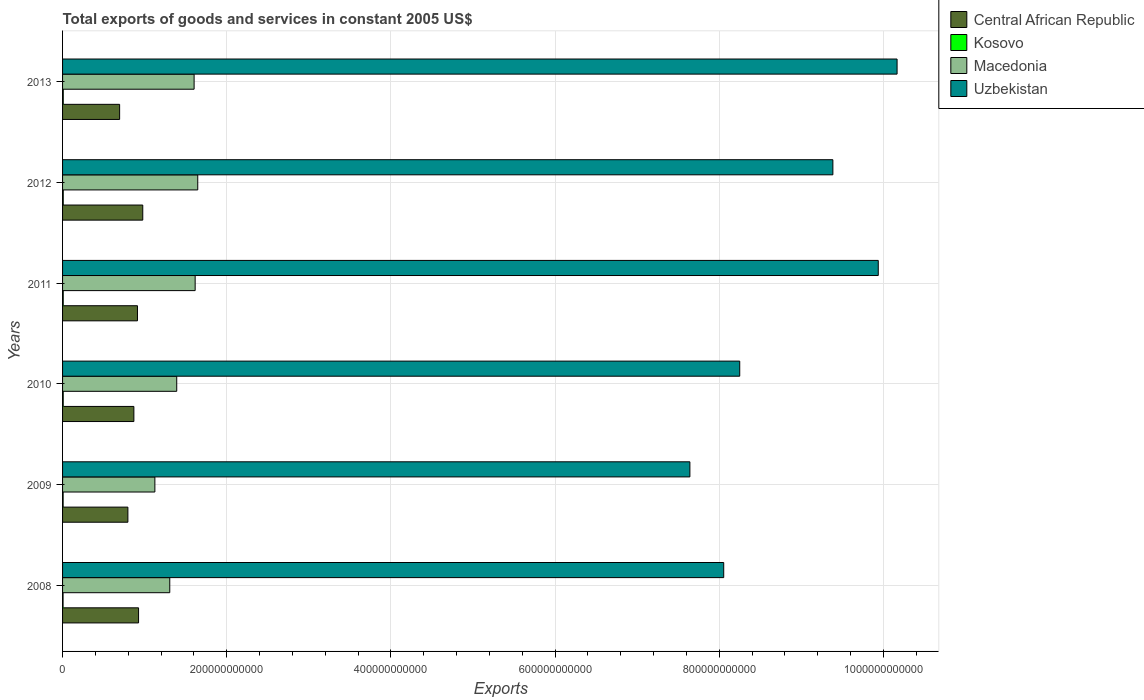How many different coloured bars are there?
Make the answer very short. 4. How many bars are there on the 4th tick from the top?
Your answer should be very brief. 4. What is the total exports of goods and services in Central African Republic in 2008?
Make the answer very short. 9.26e+1. Across all years, what is the maximum total exports of goods and services in Uzbekistan?
Offer a terse response. 1.02e+12. Across all years, what is the minimum total exports of goods and services in Central African Republic?
Ensure brevity in your answer.  6.95e+1. In which year was the total exports of goods and services in Central African Republic maximum?
Your response must be concise. 2012. In which year was the total exports of goods and services in Kosovo minimum?
Offer a very short reply. 2008. What is the total total exports of goods and services in Kosovo in the graph?
Offer a terse response. 4.49e+09. What is the difference between the total exports of goods and services in Uzbekistan in 2011 and that in 2012?
Your answer should be compact. 5.53e+1. What is the difference between the total exports of goods and services in Macedonia in 2011 and the total exports of goods and services in Uzbekistan in 2012?
Make the answer very short. -7.77e+11. What is the average total exports of goods and services in Macedonia per year?
Provide a succinct answer. 1.45e+11. In the year 2012, what is the difference between the total exports of goods and services in Central African Republic and total exports of goods and services in Uzbekistan?
Provide a short and direct response. -8.41e+11. In how many years, is the total exports of goods and services in Central African Republic greater than 480000000000 US$?
Keep it short and to the point. 0. What is the ratio of the total exports of goods and services in Uzbekistan in 2009 to that in 2013?
Your answer should be compact. 0.75. Is the total exports of goods and services in Uzbekistan in 2008 less than that in 2011?
Provide a succinct answer. Yes. Is the difference between the total exports of goods and services in Central African Republic in 2008 and 2010 greater than the difference between the total exports of goods and services in Uzbekistan in 2008 and 2010?
Your response must be concise. Yes. What is the difference between the highest and the second highest total exports of goods and services in Macedonia?
Ensure brevity in your answer.  3.15e+09. What is the difference between the highest and the lowest total exports of goods and services in Central African Republic?
Give a very brief answer. 2.82e+1. Is it the case that in every year, the sum of the total exports of goods and services in Kosovo and total exports of goods and services in Macedonia is greater than the sum of total exports of goods and services in Central African Republic and total exports of goods and services in Uzbekistan?
Provide a short and direct response. No. What does the 2nd bar from the top in 2010 represents?
Make the answer very short. Macedonia. What does the 3rd bar from the bottom in 2011 represents?
Give a very brief answer. Macedonia. How many bars are there?
Offer a very short reply. 24. What is the difference between two consecutive major ticks on the X-axis?
Your answer should be very brief. 2.00e+11. Does the graph contain any zero values?
Provide a succinct answer. No. Does the graph contain grids?
Offer a terse response. Yes. How are the legend labels stacked?
Make the answer very short. Vertical. What is the title of the graph?
Keep it short and to the point. Total exports of goods and services in constant 2005 US$. Does "Canada" appear as one of the legend labels in the graph?
Your answer should be compact. No. What is the label or title of the X-axis?
Provide a succinct answer. Exports. What is the Exports in Central African Republic in 2008?
Make the answer very short. 9.26e+1. What is the Exports in Kosovo in 2008?
Offer a terse response. 6.09e+08. What is the Exports of Macedonia in 2008?
Offer a terse response. 1.31e+11. What is the Exports of Uzbekistan in 2008?
Offer a very short reply. 8.05e+11. What is the Exports of Central African Republic in 2009?
Provide a short and direct response. 7.96e+1. What is the Exports in Kosovo in 2009?
Provide a succinct answer. 6.85e+08. What is the Exports in Macedonia in 2009?
Your answer should be compact. 1.12e+11. What is the Exports of Uzbekistan in 2009?
Ensure brevity in your answer.  7.64e+11. What is the Exports in Central African Republic in 2010?
Make the answer very short. 8.69e+1. What is the Exports of Kosovo in 2010?
Ensure brevity in your answer.  7.70e+08. What is the Exports in Macedonia in 2010?
Provide a short and direct response. 1.39e+11. What is the Exports of Uzbekistan in 2010?
Your response must be concise. 8.25e+11. What is the Exports of Central African Republic in 2011?
Make the answer very short. 9.13e+1. What is the Exports in Kosovo in 2011?
Offer a very short reply. 8.00e+08. What is the Exports of Macedonia in 2011?
Make the answer very short. 1.62e+11. What is the Exports of Uzbekistan in 2011?
Your answer should be compact. 9.94e+11. What is the Exports in Central African Republic in 2012?
Offer a terse response. 9.77e+1. What is the Exports in Kosovo in 2012?
Your answer should be very brief. 8.06e+08. What is the Exports of Macedonia in 2012?
Make the answer very short. 1.65e+11. What is the Exports in Uzbekistan in 2012?
Your response must be concise. 9.38e+11. What is the Exports in Central African Republic in 2013?
Your answer should be compact. 6.95e+1. What is the Exports in Kosovo in 2013?
Keep it short and to the point. 8.24e+08. What is the Exports of Macedonia in 2013?
Give a very brief answer. 1.60e+11. What is the Exports of Uzbekistan in 2013?
Provide a succinct answer. 1.02e+12. Across all years, what is the maximum Exports of Central African Republic?
Provide a succinct answer. 9.77e+1. Across all years, what is the maximum Exports of Kosovo?
Provide a short and direct response. 8.24e+08. Across all years, what is the maximum Exports in Macedonia?
Your answer should be very brief. 1.65e+11. Across all years, what is the maximum Exports in Uzbekistan?
Provide a succinct answer. 1.02e+12. Across all years, what is the minimum Exports of Central African Republic?
Your answer should be very brief. 6.95e+1. Across all years, what is the minimum Exports in Kosovo?
Ensure brevity in your answer.  6.09e+08. Across all years, what is the minimum Exports in Macedonia?
Offer a very short reply. 1.12e+11. Across all years, what is the minimum Exports in Uzbekistan?
Provide a succinct answer. 7.64e+11. What is the total Exports of Central African Republic in the graph?
Your response must be concise. 5.18e+11. What is the total Exports in Kosovo in the graph?
Provide a succinct answer. 4.49e+09. What is the total Exports in Macedonia in the graph?
Provide a short and direct response. 8.69e+11. What is the total Exports of Uzbekistan in the graph?
Ensure brevity in your answer.  5.34e+12. What is the difference between the Exports of Central African Republic in 2008 and that in 2009?
Make the answer very short. 1.30e+1. What is the difference between the Exports in Kosovo in 2008 and that in 2009?
Your answer should be compact. -7.59e+07. What is the difference between the Exports of Macedonia in 2008 and that in 2009?
Offer a very short reply. 1.81e+1. What is the difference between the Exports in Uzbekistan in 2008 and that in 2009?
Provide a succinct answer. 4.12e+1. What is the difference between the Exports in Central African Republic in 2008 and that in 2010?
Your response must be concise. 5.71e+09. What is the difference between the Exports of Kosovo in 2008 and that in 2010?
Your response must be concise. -1.62e+08. What is the difference between the Exports of Macedonia in 2008 and that in 2010?
Ensure brevity in your answer.  -8.49e+09. What is the difference between the Exports in Uzbekistan in 2008 and that in 2010?
Offer a terse response. -1.95e+1. What is the difference between the Exports in Central African Republic in 2008 and that in 2011?
Your response must be concise. 1.33e+09. What is the difference between the Exports of Kosovo in 2008 and that in 2011?
Your answer should be compact. -1.91e+08. What is the difference between the Exports in Macedonia in 2008 and that in 2011?
Make the answer very short. -3.09e+1. What is the difference between the Exports in Uzbekistan in 2008 and that in 2011?
Offer a very short reply. -1.88e+11. What is the difference between the Exports in Central African Republic in 2008 and that in 2012?
Offer a very short reply. -5.11e+09. What is the difference between the Exports of Kosovo in 2008 and that in 2012?
Offer a terse response. -1.97e+08. What is the difference between the Exports of Macedonia in 2008 and that in 2012?
Provide a succinct answer. -3.41e+1. What is the difference between the Exports of Uzbekistan in 2008 and that in 2012?
Give a very brief answer. -1.33e+11. What is the difference between the Exports of Central African Republic in 2008 and that in 2013?
Provide a short and direct response. 2.31e+1. What is the difference between the Exports of Kosovo in 2008 and that in 2013?
Provide a succinct answer. -2.15e+08. What is the difference between the Exports in Macedonia in 2008 and that in 2013?
Make the answer very short. -2.97e+1. What is the difference between the Exports of Uzbekistan in 2008 and that in 2013?
Keep it short and to the point. -2.11e+11. What is the difference between the Exports of Central African Republic in 2009 and that in 2010?
Your answer should be compact. -7.29e+09. What is the difference between the Exports in Kosovo in 2009 and that in 2010?
Your response must be concise. -8.56e+07. What is the difference between the Exports of Macedonia in 2009 and that in 2010?
Give a very brief answer. -2.66e+1. What is the difference between the Exports in Uzbekistan in 2009 and that in 2010?
Your answer should be compact. -6.07e+1. What is the difference between the Exports of Central African Republic in 2009 and that in 2011?
Give a very brief answer. -1.17e+1. What is the difference between the Exports in Kosovo in 2009 and that in 2011?
Your answer should be very brief. -1.15e+08. What is the difference between the Exports in Macedonia in 2009 and that in 2011?
Make the answer very short. -4.91e+1. What is the difference between the Exports of Uzbekistan in 2009 and that in 2011?
Give a very brief answer. -2.29e+11. What is the difference between the Exports in Central African Republic in 2009 and that in 2012?
Provide a short and direct response. -1.81e+1. What is the difference between the Exports of Kosovo in 2009 and that in 2012?
Your answer should be compact. -1.21e+08. What is the difference between the Exports in Macedonia in 2009 and that in 2012?
Ensure brevity in your answer.  -5.22e+1. What is the difference between the Exports in Uzbekistan in 2009 and that in 2012?
Make the answer very short. -1.74e+11. What is the difference between the Exports of Central African Republic in 2009 and that in 2013?
Ensure brevity in your answer.  1.01e+1. What is the difference between the Exports of Kosovo in 2009 and that in 2013?
Ensure brevity in your answer.  -1.39e+08. What is the difference between the Exports of Macedonia in 2009 and that in 2013?
Ensure brevity in your answer.  -4.78e+1. What is the difference between the Exports in Uzbekistan in 2009 and that in 2013?
Ensure brevity in your answer.  -2.52e+11. What is the difference between the Exports of Central African Republic in 2010 and that in 2011?
Ensure brevity in your answer.  -4.38e+09. What is the difference between the Exports of Kosovo in 2010 and that in 2011?
Offer a terse response. -2.96e+07. What is the difference between the Exports in Macedonia in 2010 and that in 2011?
Provide a succinct answer. -2.24e+1. What is the difference between the Exports of Uzbekistan in 2010 and that in 2011?
Give a very brief answer. -1.69e+11. What is the difference between the Exports in Central African Republic in 2010 and that in 2012?
Give a very brief answer. -1.08e+1. What is the difference between the Exports of Kosovo in 2010 and that in 2012?
Give a very brief answer. -3.52e+07. What is the difference between the Exports in Macedonia in 2010 and that in 2012?
Provide a succinct answer. -2.56e+1. What is the difference between the Exports of Uzbekistan in 2010 and that in 2012?
Give a very brief answer. -1.13e+11. What is the difference between the Exports of Central African Republic in 2010 and that in 2013?
Give a very brief answer. 1.74e+1. What is the difference between the Exports in Kosovo in 2010 and that in 2013?
Offer a very short reply. -5.38e+07. What is the difference between the Exports in Macedonia in 2010 and that in 2013?
Your answer should be compact. -2.12e+1. What is the difference between the Exports in Uzbekistan in 2010 and that in 2013?
Your answer should be compact. -1.92e+11. What is the difference between the Exports of Central African Republic in 2011 and that in 2012?
Make the answer very short. -6.44e+09. What is the difference between the Exports of Kosovo in 2011 and that in 2012?
Offer a terse response. -5.60e+06. What is the difference between the Exports in Macedonia in 2011 and that in 2012?
Make the answer very short. -3.15e+09. What is the difference between the Exports in Uzbekistan in 2011 and that in 2012?
Ensure brevity in your answer.  5.53e+1. What is the difference between the Exports of Central African Republic in 2011 and that in 2013?
Your answer should be compact. 2.17e+1. What is the difference between the Exports of Kosovo in 2011 and that in 2013?
Ensure brevity in your answer.  -2.42e+07. What is the difference between the Exports of Macedonia in 2011 and that in 2013?
Provide a succinct answer. 1.27e+09. What is the difference between the Exports in Uzbekistan in 2011 and that in 2013?
Your answer should be compact. -2.29e+1. What is the difference between the Exports in Central African Republic in 2012 and that in 2013?
Give a very brief answer. 2.82e+1. What is the difference between the Exports of Kosovo in 2012 and that in 2013?
Your answer should be very brief. -1.86e+07. What is the difference between the Exports in Macedonia in 2012 and that in 2013?
Provide a short and direct response. 4.42e+09. What is the difference between the Exports of Uzbekistan in 2012 and that in 2013?
Provide a succinct answer. -7.82e+1. What is the difference between the Exports in Central African Republic in 2008 and the Exports in Kosovo in 2009?
Provide a short and direct response. 9.19e+1. What is the difference between the Exports in Central African Republic in 2008 and the Exports in Macedonia in 2009?
Your answer should be very brief. -1.99e+1. What is the difference between the Exports in Central African Republic in 2008 and the Exports in Uzbekistan in 2009?
Offer a very short reply. -6.72e+11. What is the difference between the Exports in Kosovo in 2008 and the Exports in Macedonia in 2009?
Keep it short and to the point. -1.12e+11. What is the difference between the Exports of Kosovo in 2008 and the Exports of Uzbekistan in 2009?
Your response must be concise. -7.64e+11. What is the difference between the Exports of Macedonia in 2008 and the Exports of Uzbekistan in 2009?
Offer a very short reply. -6.34e+11. What is the difference between the Exports of Central African Republic in 2008 and the Exports of Kosovo in 2010?
Provide a short and direct response. 9.18e+1. What is the difference between the Exports of Central African Republic in 2008 and the Exports of Macedonia in 2010?
Provide a succinct answer. -4.65e+1. What is the difference between the Exports of Central African Republic in 2008 and the Exports of Uzbekistan in 2010?
Ensure brevity in your answer.  -7.32e+11. What is the difference between the Exports in Kosovo in 2008 and the Exports in Macedonia in 2010?
Give a very brief answer. -1.38e+11. What is the difference between the Exports in Kosovo in 2008 and the Exports in Uzbekistan in 2010?
Your answer should be very brief. -8.24e+11. What is the difference between the Exports in Macedonia in 2008 and the Exports in Uzbekistan in 2010?
Your response must be concise. -6.94e+11. What is the difference between the Exports in Central African Republic in 2008 and the Exports in Kosovo in 2011?
Provide a succinct answer. 9.18e+1. What is the difference between the Exports in Central African Republic in 2008 and the Exports in Macedonia in 2011?
Make the answer very short. -6.89e+1. What is the difference between the Exports in Central African Republic in 2008 and the Exports in Uzbekistan in 2011?
Keep it short and to the point. -9.01e+11. What is the difference between the Exports in Kosovo in 2008 and the Exports in Macedonia in 2011?
Ensure brevity in your answer.  -1.61e+11. What is the difference between the Exports of Kosovo in 2008 and the Exports of Uzbekistan in 2011?
Your answer should be very brief. -9.93e+11. What is the difference between the Exports in Macedonia in 2008 and the Exports in Uzbekistan in 2011?
Your answer should be compact. -8.63e+11. What is the difference between the Exports of Central African Republic in 2008 and the Exports of Kosovo in 2012?
Your answer should be very brief. 9.18e+1. What is the difference between the Exports of Central African Republic in 2008 and the Exports of Macedonia in 2012?
Provide a succinct answer. -7.21e+1. What is the difference between the Exports in Central African Republic in 2008 and the Exports in Uzbekistan in 2012?
Your response must be concise. -8.46e+11. What is the difference between the Exports of Kosovo in 2008 and the Exports of Macedonia in 2012?
Offer a very short reply. -1.64e+11. What is the difference between the Exports of Kosovo in 2008 and the Exports of Uzbekistan in 2012?
Offer a very short reply. -9.38e+11. What is the difference between the Exports in Macedonia in 2008 and the Exports in Uzbekistan in 2012?
Your response must be concise. -8.08e+11. What is the difference between the Exports in Central African Republic in 2008 and the Exports in Kosovo in 2013?
Ensure brevity in your answer.  9.18e+1. What is the difference between the Exports in Central African Republic in 2008 and the Exports in Macedonia in 2013?
Ensure brevity in your answer.  -6.77e+1. What is the difference between the Exports of Central African Republic in 2008 and the Exports of Uzbekistan in 2013?
Keep it short and to the point. -9.24e+11. What is the difference between the Exports in Kosovo in 2008 and the Exports in Macedonia in 2013?
Keep it short and to the point. -1.60e+11. What is the difference between the Exports in Kosovo in 2008 and the Exports in Uzbekistan in 2013?
Your response must be concise. -1.02e+12. What is the difference between the Exports in Macedonia in 2008 and the Exports in Uzbekistan in 2013?
Offer a terse response. -8.86e+11. What is the difference between the Exports in Central African Republic in 2009 and the Exports in Kosovo in 2010?
Your answer should be compact. 7.88e+1. What is the difference between the Exports of Central African Republic in 2009 and the Exports of Macedonia in 2010?
Your response must be concise. -5.95e+1. What is the difference between the Exports of Central African Republic in 2009 and the Exports of Uzbekistan in 2010?
Ensure brevity in your answer.  -7.45e+11. What is the difference between the Exports in Kosovo in 2009 and the Exports in Macedonia in 2010?
Your answer should be compact. -1.38e+11. What is the difference between the Exports in Kosovo in 2009 and the Exports in Uzbekistan in 2010?
Provide a succinct answer. -8.24e+11. What is the difference between the Exports of Macedonia in 2009 and the Exports of Uzbekistan in 2010?
Provide a short and direct response. -7.13e+11. What is the difference between the Exports in Central African Republic in 2009 and the Exports in Kosovo in 2011?
Ensure brevity in your answer.  7.88e+1. What is the difference between the Exports of Central African Republic in 2009 and the Exports of Macedonia in 2011?
Make the answer very short. -8.19e+1. What is the difference between the Exports in Central African Republic in 2009 and the Exports in Uzbekistan in 2011?
Provide a short and direct response. -9.14e+11. What is the difference between the Exports of Kosovo in 2009 and the Exports of Macedonia in 2011?
Keep it short and to the point. -1.61e+11. What is the difference between the Exports in Kosovo in 2009 and the Exports in Uzbekistan in 2011?
Your answer should be very brief. -9.93e+11. What is the difference between the Exports of Macedonia in 2009 and the Exports of Uzbekistan in 2011?
Your answer should be compact. -8.81e+11. What is the difference between the Exports in Central African Republic in 2009 and the Exports in Kosovo in 2012?
Keep it short and to the point. 7.88e+1. What is the difference between the Exports in Central African Republic in 2009 and the Exports in Macedonia in 2012?
Your answer should be very brief. -8.51e+1. What is the difference between the Exports of Central African Republic in 2009 and the Exports of Uzbekistan in 2012?
Offer a terse response. -8.59e+11. What is the difference between the Exports of Kosovo in 2009 and the Exports of Macedonia in 2012?
Provide a succinct answer. -1.64e+11. What is the difference between the Exports of Kosovo in 2009 and the Exports of Uzbekistan in 2012?
Offer a terse response. -9.38e+11. What is the difference between the Exports in Macedonia in 2009 and the Exports in Uzbekistan in 2012?
Provide a succinct answer. -8.26e+11. What is the difference between the Exports of Central African Republic in 2009 and the Exports of Kosovo in 2013?
Provide a short and direct response. 7.88e+1. What is the difference between the Exports of Central African Republic in 2009 and the Exports of Macedonia in 2013?
Your answer should be compact. -8.07e+1. What is the difference between the Exports in Central African Republic in 2009 and the Exports in Uzbekistan in 2013?
Offer a very short reply. -9.37e+11. What is the difference between the Exports of Kosovo in 2009 and the Exports of Macedonia in 2013?
Provide a succinct answer. -1.60e+11. What is the difference between the Exports of Kosovo in 2009 and the Exports of Uzbekistan in 2013?
Make the answer very short. -1.02e+12. What is the difference between the Exports of Macedonia in 2009 and the Exports of Uzbekistan in 2013?
Provide a short and direct response. -9.04e+11. What is the difference between the Exports of Central African Republic in 2010 and the Exports of Kosovo in 2011?
Provide a short and direct response. 8.61e+1. What is the difference between the Exports in Central African Republic in 2010 and the Exports in Macedonia in 2011?
Offer a very short reply. -7.47e+1. What is the difference between the Exports in Central African Republic in 2010 and the Exports in Uzbekistan in 2011?
Provide a short and direct response. -9.07e+11. What is the difference between the Exports in Kosovo in 2010 and the Exports in Macedonia in 2011?
Your answer should be very brief. -1.61e+11. What is the difference between the Exports in Kosovo in 2010 and the Exports in Uzbekistan in 2011?
Provide a succinct answer. -9.93e+11. What is the difference between the Exports of Macedonia in 2010 and the Exports of Uzbekistan in 2011?
Give a very brief answer. -8.55e+11. What is the difference between the Exports in Central African Republic in 2010 and the Exports in Kosovo in 2012?
Provide a succinct answer. 8.61e+1. What is the difference between the Exports of Central African Republic in 2010 and the Exports of Macedonia in 2012?
Keep it short and to the point. -7.78e+1. What is the difference between the Exports in Central African Republic in 2010 and the Exports in Uzbekistan in 2012?
Your response must be concise. -8.52e+11. What is the difference between the Exports in Kosovo in 2010 and the Exports in Macedonia in 2012?
Give a very brief answer. -1.64e+11. What is the difference between the Exports in Kosovo in 2010 and the Exports in Uzbekistan in 2012?
Keep it short and to the point. -9.38e+11. What is the difference between the Exports of Macedonia in 2010 and the Exports of Uzbekistan in 2012?
Your response must be concise. -7.99e+11. What is the difference between the Exports in Central African Republic in 2010 and the Exports in Kosovo in 2013?
Ensure brevity in your answer.  8.61e+1. What is the difference between the Exports in Central African Republic in 2010 and the Exports in Macedonia in 2013?
Your response must be concise. -7.34e+1. What is the difference between the Exports of Central African Republic in 2010 and the Exports of Uzbekistan in 2013?
Offer a very short reply. -9.30e+11. What is the difference between the Exports of Kosovo in 2010 and the Exports of Macedonia in 2013?
Ensure brevity in your answer.  -1.59e+11. What is the difference between the Exports in Kosovo in 2010 and the Exports in Uzbekistan in 2013?
Provide a short and direct response. -1.02e+12. What is the difference between the Exports of Macedonia in 2010 and the Exports of Uzbekistan in 2013?
Your answer should be very brief. -8.78e+11. What is the difference between the Exports of Central African Republic in 2011 and the Exports of Kosovo in 2012?
Make the answer very short. 9.05e+1. What is the difference between the Exports in Central African Republic in 2011 and the Exports in Macedonia in 2012?
Ensure brevity in your answer.  -7.34e+1. What is the difference between the Exports in Central African Republic in 2011 and the Exports in Uzbekistan in 2012?
Your answer should be very brief. -8.47e+11. What is the difference between the Exports of Kosovo in 2011 and the Exports of Macedonia in 2012?
Make the answer very short. -1.64e+11. What is the difference between the Exports in Kosovo in 2011 and the Exports in Uzbekistan in 2012?
Make the answer very short. -9.38e+11. What is the difference between the Exports in Macedonia in 2011 and the Exports in Uzbekistan in 2012?
Your answer should be compact. -7.77e+11. What is the difference between the Exports in Central African Republic in 2011 and the Exports in Kosovo in 2013?
Provide a short and direct response. 9.04e+1. What is the difference between the Exports in Central African Republic in 2011 and the Exports in Macedonia in 2013?
Your response must be concise. -6.90e+1. What is the difference between the Exports of Central African Republic in 2011 and the Exports of Uzbekistan in 2013?
Make the answer very short. -9.25e+11. What is the difference between the Exports in Kosovo in 2011 and the Exports in Macedonia in 2013?
Provide a short and direct response. -1.59e+11. What is the difference between the Exports in Kosovo in 2011 and the Exports in Uzbekistan in 2013?
Give a very brief answer. -1.02e+12. What is the difference between the Exports of Macedonia in 2011 and the Exports of Uzbekistan in 2013?
Your response must be concise. -8.55e+11. What is the difference between the Exports of Central African Republic in 2012 and the Exports of Kosovo in 2013?
Offer a terse response. 9.69e+1. What is the difference between the Exports in Central African Republic in 2012 and the Exports in Macedonia in 2013?
Offer a very short reply. -6.26e+1. What is the difference between the Exports in Central African Republic in 2012 and the Exports in Uzbekistan in 2013?
Keep it short and to the point. -9.19e+11. What is the difference between the Exports in Kosovo in 2012 and the Exports in Macedonia in 2013?
Provide a succinct answer. -1.59e+11. What is the difference between the Exports of Kosovo in 2012 and the Exports of Uzbekistan in 2013?
Offer a terse response. -1.02e+12. What is the difference between the Exports of Macedonia in 2012 and the Exports of Uzbekistan in 2013?
Your answer should be compact. -8.52e+11. What is the average Exports in Central African Republic per year?
Make the answer very short. 8.63e+1. What is the average Exports of Kosovo per year?
Ensure brevity in your answer.  7.49e+08. What is the average Exports of Macedonia per year?
Keep it short and to the point. 1.45e+11. What is the average Exports in Uzbekistan per year?
Make the answer very short. 8.91e+11. In the year 2008, what is the difference between the Exports of Central African Republic and Exports of Kosovo?
Offer a very short reply. 9.20e+1. In the year 2008, what is the difference between the Exports of Central African Republic and Exports of Macedonia?
Ensure brevity in your answer.  -3.80e+1. In the year 2008, what is the difference between the Exports in Central African Republic and Exports in Uzbekistan?
Give a very brief answer. -7.13e+11. In the year 2008, what is the difference between the Exports of Kosovo and Exports of Macedonia?
Make the answer very short. -1.30e+11. In the year 2008, what is the difference between the Exports of Kosovo and Exports of Uzbekistan?
Provide a short and direct response. -8.05e+11. In the year 2008, what is the difference between the Exports of Macedonia and Exports of Uzbekistan?
Provide a succinct answer. -6.75e+11. In the year 2009, what is the difference between the Exports in Central African Republic and Exports in Kosovo?
Give a very brief answer. 7.89e+1. In the year 2009, what is the difference between the Exports of Central African Republic and Exports of Macedonia?
Ensure brevity in your answer.  -3.29e+1. In the year 2009, what is the difference between the Exports in Central African Republic and Exports in Uzbekistan?
Your response must be concise. -6.85e+11. In the year 2009, what is the difference between the Exports in Kosovo and Exports in Macedonia?
Give a very brief answer. -1.12e+11. In the year 2009, what is the difference between the Exports of Kosovo and Exports of Uzbekistan?
Make the answer very short. -7.64e+11. In the year 2009, what is the difference between the Exports of Macedonia and Exports of Uzbekistan?
Give a very brief answer. -6.52e+11. In the year 2010, what is the difference between the Exports in Central African Republic and Exports in Kosovo?
Provide a short and direct response. 8.61e+1. In the year 2010, what is the difference between the Exports of Central African Republic and Exports of Macedonia?
Make the answer very short. -5.22e+1. In the year 2010, what is the difference between the Exports of Central African Republic and Exports of Uzbekistan?
Offer a very short reply. -7.38e+11. In the year 2010, what is the difference between the Exports of Kosovo and Exports of Macedonia?
Your answer should be compact. -1.38e+11. In the year 2010, what is the difference between the Exports of Kosovo and Exports of Uzbekistan?
Provide a short and direct response. -8.24e+11. In the year 2010, what is the difference between the Exports of Macedonia and Exports of Uzbekistan?
Offer a terse response. -6.86e+11. In the year 2011, what is the difference between the Exports of Central African Republic and Exports of Kosovo?
Provide a succinct answer. 9.05e+1. In the year 2011, what is the difference between the Exports in Central African Republic and Exports in Macedonia?
Provide a short and direct response. -7.03e+1. In the year 2011, what is the difference between the Exports in Central African Republic and Exports in Uzbekistan?
Offer a terse response. -9.02e+11. In the year 2011, what is the difference between the Exports of Kosovo and Exports of Macedonia?
Offer a terse response. -1.61e+11. In the year 2011, what is the difference between the Exports of Kosovo and Exports of Uzbekistan?
Offer a terse response. -9.93e+11. In the year 2011, what is the difference between the Exports in Macedonia and Exports in Uzbekistan?
Your answer should be compact. -8.32e+11. In the year 2012, what is the difference between the Exports of Central African Republic and Exports of Kosovo?
Offer a terse response. 9.69e+1. In the year 2012, what is the difference between the Exports in Central African Republic and Exports in Macedonia?
Keep it short and to the point. -6.70e+1. In the year 2012, what is the difference between the Exports of Central African Republic and Exports of Uzbekistan?
Give a very brief answer. -8.41e+11. In the year 2012, what is the difference between the Exports in Kosovo and Exports in Macedonia?
Make the answer very short. -1.64e+11. In the year 2012, what is the difference between the Exports in Kosovo and Exports in Uzbekistan?
Your answer should be compact. -9.38e+11. In the year 2012, what is the difference between the Exports in Macedonia and Exports in Uzbekistan?
Give a very brief answer. -7.74e+11. In the year 2013, what is the difference between the Exports in Central African Republic and Exports in Kosovo?
Ensure brevity in your answer.  6.87e+1. In the year 2013, what is the difference between the Exports in Central African Republic and Exports in Macedonia?
Your response must be concise. -9.08e+1. In the year 2013, what is the difference between the Exports in Central African Republic and Exports in Uzbekistan?
Provide a succinct answer. -9.47e+11. In the year 2013, what is the difference between the Exports in Kosovo and Exports in Macedonia?
Make the answer very short. -1.59e+11. In the year 2013, what is the difference between the Exports in Kosovo and Exports in Uzbekistan?
Offer a very short reply. -1.02e+12. In the year 2013, what is the difference between the Exports in Macedonia and Exports in Uzbekistan?
Your response must be concise. -8.56e+11. What is the ratio of the Exports of Central African Republic in 2008 to that in 2009?
Give a very brief answer. 1.16. What is the ratio of the Exports of Kosovo in 2008 to that in 2009?
Offer a terse response. 0.89. What is the ratio of the Exports in Macedonia in 2008 to that in 2009?
Offer a terse response. 1.16. What is the ratio of the Exports of Uzbekistan in 2008 to that in 2009?
Offer a terse response. 1.05. What is the ratio of the Exports in Central African Republic in 2008 to that in 2010?
Your response must be concise. 1.07. What is the ratio of the Exports of Kosovo in 2008 to that in 2010?
Provide a succinct answer. 0.79. What is the ratio of the Exports in Macedonia in 2008 to that in 2010?
Provide a short and direct response. 0.94. What is the ratio of the Exports in Uzbekistan in 2008 to that in 2010?
Ensure brevity in your answer.  0.98. What is the ratio of the Exports in Central African Republic in 2008 to that in 2011?
Provide a short and direct response. 1.01. What is the ratio of the Exports in Kosovo in 2008 to that in 2011?
Offer a very short reply. 0.76. What is the ratio of the Exports in Macedonia in 2008 to that in 2011?
Ensure brevity in your answer.  0.81. What is the ratio of the Exports of Uzbekistan in 2008 to that in 2011?
Provide a succinct answer. 0.81. What is the ratio of the Exports of Central African Republic in 2008 to that in 2012?
Ensure brevity in your answer.  0.95. What is the ratio of the Exports of Kosovo in 2008 to that in 2012?
Offer a terse response. 0.76. What is the ratio of the Exports in Macedonia in 2008 to that in 2012?
Provide a short and direct response. 0.79. What is the ratio of the Exports in Uzbekistan in 2008 to that in 2012?
Make the answer very short. 0.86. What is the ratio of the Exports of Central African Republic in 2008 to that in 2013?
Make the answer very short. 1.33. What is the ratio of the Exports in Kosovo in 2008 to that in 2013?
Offer a terse response. 0.74. What is the ratio of the Exports of Macedonia in 2008 to that in 2013?
Your response must be concise. 0.81. What is the ratio of the Exports of Uzbekistan in 2008 to that in 2013?
Provide a succinct answer. 0.79. What is the ratio of the Exports in Central African Republic in 2009 to that in 2010?
Provide a succinct answer. 0.92. What is the ratio of the Exports in Macedonia in 2009 to that in 2010?
Ensure brevity in your answer.  0.81. What is the ratio of the Exports in Uzbekistan in 2009 to that in 2010?
Your answer should be very brief. 0.93. What is the ratio of the Exports in Central African Republic in 2009 to that in 2011?
Your answer should be compact. 0.87. What is the ratio of the Exports in Kosovo in 2009 to that in 2011?
Make the answer very short. 0.86. What is the ratio of the Exports in Macedonia in 2009 to that in 2011?
Give a very brief answer. 0.7. What is the ratio of the Exports of Uzbekistan in 2009 to that in 2011?
Keep it short and to the point. 0.77. What is the ratio of the Exports in Central African Republic in 2009 to that in 2012?
Your answer should be compact. 0.81. What is the ratio of the Exports of Macedonia in 2009 to that in 2012?
Offer a very short reply. 0.68. What is the ratio of the Exports in Uzbekistan in 2009 to that in 2012?
Your answer should be compact. 0.81. What is the ratio of the Exports of Central African Republic in 2009 to that in 2013?
Offer a terse response. 1.14. What is the ratio of the Exports in Kosovo in 2009 to that in 2013?
Your answer should be very brief. 0.83. What is the ratio of the Exports of Macedonia in 2009 to that in 2013?
Keep it short and to the point. 0.7. What is the ratio of the Exports of Uzbekistan in 2009 to that in 2013?
Ensure brevity in your answer.  0.75. What is the ratio of the Exports of Central African Republic in 2010 to that in 2011?
Your response must be concise. 0.95. What is the ratio of the Exports of Macedonia in 2010 to that in 2011?
Give a very brief answer. 0.86. What is the ratio of the Exports of Uzbekistan in 2010 to that in 2011?
Keep it short and to the point. 0.83. What is the ratio of the Exports of Central African Republic in 2010 to that in 2012?
Ensure brevity in your answer.  0.89. What is the ratio of the Exports of Kosovo in 2010 to that in 2012?
Offer a terse response. 0.96. What is the ratio of the Exports in Macedonia in 2010 to that in 2012?
Make the answer very short. 0.84. What is the ratio of the Exports of Uzbekistan in 2010 to that in 2012?
Keep it short and to the point. 0.88. What is the ratio of the Exports of Central African Republic in 2010 to that in 2013?
Your response must be concise. 1.25. What is the ratio of the Exports in Kosovo in 2010 to that in 2013?
Provide a succinct answer. 0.93. What is the ratio of the Exports of Macedonia in 2010 to that in 2013?
Keep it short and to the point. 0.87. What is the ratio of the Exports in Uzbekistan in 2010 to that in 2013?
Your answer should be compact. 0.81. What is the ratio of the Exports of Central African Republic in 2011 to that in 2012?
Your response must be concise. 0.93. What is the ratio of the Exports in Kosovo in 2011 to that in 2012?
Keep it short and to the point. 0.99. What is the ratio of the Exports of Macedonia in 2011 to that in 2012?
Offer a very short reply. 0.98. What is the ratio of the Exports of Uzbekistan in 2011 to that in 2012?
Provide a short and direct response. 1.06. What is the ratio of the Exports in Central African Republic in 2011 to that in 2013?
Your answer should be very brief. 1.31. What is the ratio of the Exports in Kosovo in 2011 to that in 2013?
Your answer should be very brief. 0.97. What is the ratio of the Exports of Macedonia in 2011 to that in 2013?
Your answer should be compact. 1.01. What is the ratio of the Exports of Uzbekistan in 2011 to that in 2013?
Offer a very short reply. 0.98. What is the ratio of the Exports of Central African Republic in 2012 to that in 2013?
Make the answer very short. 1.41. What is the ratio of the Exports of Kosovo in 2012 to that in 2013?
Keep it short and to the point. 0.98. What is the ratio of the Exports of Macedonia in 2012 to that in 2013?
Your response must be concise. 1.03. What is the ratio of the Exports in Uzbekistan in 2012 to that in 2013?
Offer a very short reply. 0.92. What is the difference between the highest and the second highest Exports in Central African Republic?
Offer a very short reply. 5.11e+09. What is the difference between the highest and the second highest Exports of Kosovo?
Provide a succinct answer. 1.86e+07. What is the difference between the highest and the second highest Exports in Macedonia?
Ensure brevity in your answer.  3.15e+09. What is the difference between the highest and the second highest Exports in Uzbekistan?
Provide a succinct answer. 2.29e+1. What is the difference between the highest and the lowest Exports of Central African Republic?
Your answer should be very brief. 2.82e+1. What is the difference between the highest and the lowest Exports in Kosovo?
Give a very brief answer. 2.15e+08. What is the difference between the highest and the lowest Exports in Macedonia?
Your answer should be very brief. 5.22e+1. What is the difference between the highest and the lowest Exports of Uzbekistan?
Keep it short and to the point. 2.52e+11. 